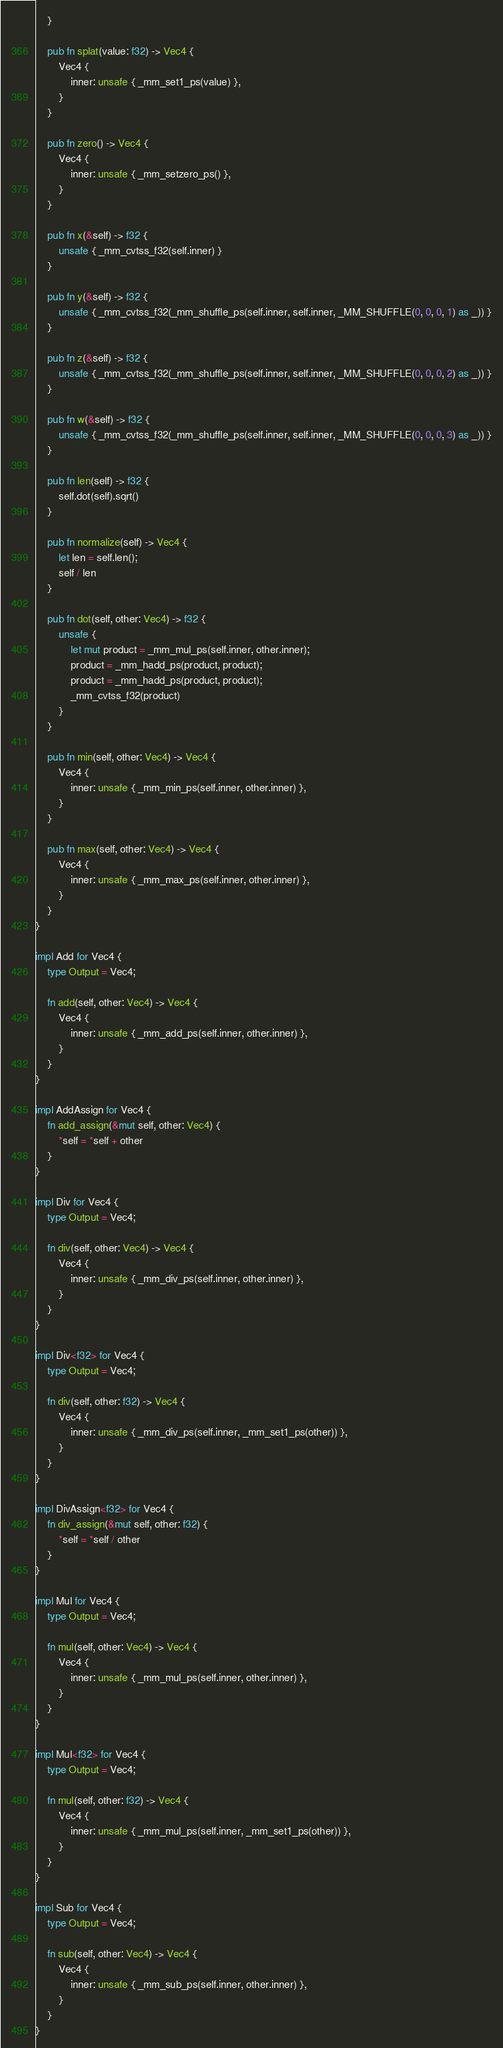<code> <loc_0><loc_0><loc_500><loc_500><_Rust_>    }

    pub fn splat(value: f32) -> Vec4 {
        Vec4 {
            inner: unsafe { _mm_set1_ps(value) },
        }
    }

    pub fn zero() -> Vec4 {
        Vec4 {
            inner: unsafe { _mm_setzero_ps() },
        }
    }

    pub fn x(&self) -> f32 {
        unsafe { _mm_cvtss_f32(self.inner) }
    }

    pub fn y(&self) -> f32 {
        unsafe { _mm_cvtss_f32(_mm_shuffle_ps(self.inner, self.inner, _MM_SHUFFLE(0, 0, 0, 1) as _)) }
    }

    pub fn z(&self) -> f32 {
        unsafe { _mm_cvtss_f32(_mm_shuffle_ps(self.inner, self.inner, _MM_SHUFFLE(0, 0, 0, 2) as _)) }
    }

    pub fn w(&self) -> f32 {
        unsafe { _mm_cvtss_f32(_mm_shuffle_ps(self.inner, self.inner, _MM_SHUFFLE(0, 0, 0, 3) as _)) }
    }

    pub fn len(self) -> f32 {
        self.dot(self).sqrt()
    }

    pub fn normalize(self) -> Vec4 {
        let len = self.len();
        self / len
    }

    pub fn dot(self, other: Vec4) -> f32 {
        unsafe {
            let mut product = _mm_mul_ps(self.inner, other.inner);
            product = _mm_hadd_ps(product, product);
            product = _mm_hadd_ps(product, product);
            _mm_cvtss_f32(product)
        }
    }

    pub fn min(self, other: Vec4) -> Vec4 {
        Vec4 {
            inner: unsafe { _mm_min_ps(self.inner, other.inner) },
        }
    }

    pub fn max(self, other: Vec4) -> Vec4 {
        Vec4 {
            inner: unsafe { _mm_max_ps(self.inner, other.inner) },
        }
    }
}

impl Add for Vec4 {
    type Output = Vec4;

    fn add(self, other: Vec4) -> Vec4 {
        Vec4 {
            inner: unsafe { _mm_add_ps(self.inner, other.inner) },
        }
    }
}

impl AddAssign for Vec4 {
    fn add_assign(&mut self, other: Vec4) {
        *self = *self + other
    }
}

impl Div for Vec4 {
    type Output = Vec4;

    fn div(self, other: Vec4) -> Vec4 {
        Vec4 {
            inner: unsafe { _mm_div_ps(self.inner, other.inner) },
        }
    }
}

impl Div<f32> for Vec4 {
    type Output = Vec4;

    fn div(self, other: f32) -> Vec4 {
        Vec4 {
            inner: unsafe { _mm_div_ps(self.inner, _mm_set1_ps(other)) },
        }
    }
}

impl DivAssign<f32> for Vec4 {
    fn div_assign(&mut self, other: f32) {
        *self = *self / other
    }
}

impl Mul for Vec4 {
    type Output = Vec4;

    fn mul(self, other: Vec4) -> Vec4 {
        Vec4 {
            inner: unsafe { _mm_mul_ps(self.inner, other.inner) },
        }
    }
}

impl Mul<f32> for Vec4 {
    type Output = Vec4;

    fn mul(self, other: f32) -> Vec4 {
        Vec4 {
            inner: unsafe { _mm_mul_ps(self.inner, _mm_set1_ps(other)) },
        }
    }
}

impl Sub for Vec4 {
    type Output = Vec4;

    fn sub(self, other: Vec4) -> Vec4 {
        Vec4 {
            inner: unsafe { _mm_sub_ps(self.inner, other.inner) },
        }
    }
}
</code> 